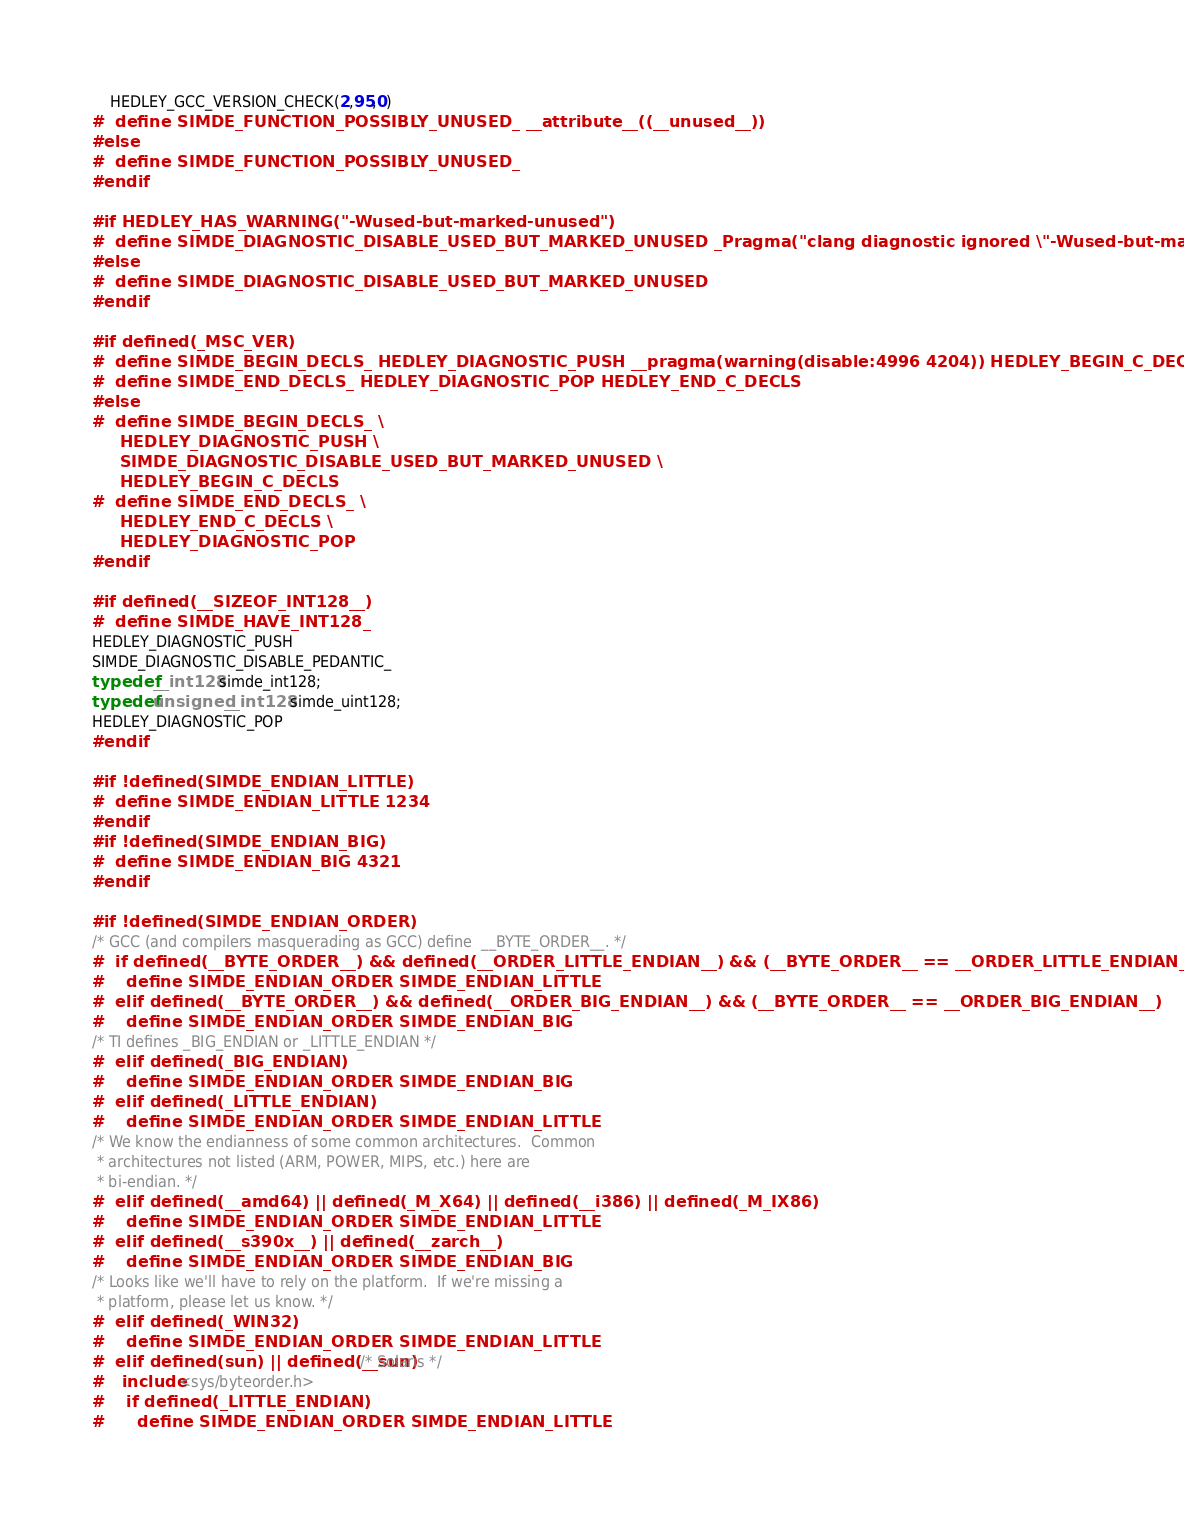<code> <loc_0><loc_0><loc_500><loc_500><_C_>    HEDLEY_GCC_VERSION_CHECK(2,95,0)
#  define SIMDE_FUNCTION_POSSIBLY_UNUSED_ __attribute__((__unused__))
#else
#  define SIMDE_FUNCTION_POSSIBLY_UNUSED_
#endif

#if HEDLEY_HAS_WARNING("-Wused-but-marked-unused")
#  define SIMDE_DIAGNOSTIC_DISABLE_USED_BUT_MARKED_UNUSED _Pragma("clang diagnostic ignored \"-Wused-but-marked-unused\"")
#else
#  define SIMDE_DIAGNOSTIC_DISABLE_USED_BUT_MARKED_UNUSED
#endif

#if defined(_MSC_VER)
#  define SIMDE_BEGIN_DECLS_ HEDLEY_DIAGNOSTIC_PUSH __pragma(warning(disable:4996 4204)) HEDLEY_BEGIN_C_DECLS
#  define SIMDE_END_DECLS_ HEDLEY_DIAGNOSTIC_POP HEDLEY_END_C_DECLS
#else
#  define SIMDE_BEGIN_DECLS_ \
     HEDLEY_DIAGNOSTIC_PUSH \
     SIMDE_DIAGNOSTIC_DISABLE_USED_BUT_MARKED_UNUSED \
     HEDLEY_BEGIN_C_DECLS
#  define SIMDE_END_DECLS_ \
     HEDLEY_END_C_DECLS \
     HEDLEY_DIAGNOSTIC_POP
#endif

#if defined(__SIZEOF_INT128__)
#  define SIMDE_HAVE_INT128_
HEDLEY_DIAGNOSTIC_PUSH
SIMDE_DIAGNOSTIC_DISABLE_PEDANTIC_
typedef __int128 simde_int128;
typedef unsigned __int128 simde_uint128;
HEDLEY_DIAGNOSTIC_POP
#endif

#if !defined(SIMDE_ENDIAN_LITTLE)
#  define SIMDE_ENDIAN_LITTLE 1234
#endif
#if !defined(SIMDE_ENDIAN_BIG)
#  define SIMDE_ENDIAN_BIG 4321
#endif

#if !defined(SIMDE_ENDIAN_ORDER)
/* GCC (and compilers masquerading as GCC) define  __BYTE_ORDER__. */
#  if defined(__BYTE_ORDER__) && defined(__ORDER_LITTLE_ENDIAN__) && (__BYTE_ORDER__ == __ORDER_LITTLE_ENDIAN__)
#    define SIMDE_ENDIAN_ORDER SIMDE_ENDIAN_LITTLE
#  elif defined(__BYTE_ORDER__) && defined(__ORDER_BIG_ENDIAN__) && (__BYTE_ORDER__ == __ORDER_BIG_ENDIAN__)
#    define SIMDE_ENDIAN_ORDER SIMDE_ENDIAN_BIG
/* TI defines _BIG_ENDIAN or _LITTLE_ENDIAN */
#  elif defined(_BIG_ENDIAN)
#    define SIMDE_ENDIAN_ORDER SIMDE_ENDIAN_BIG
#  elif defined(_LITTLE_ENDIAN)
#    define SIMDE_ENDIAN_ORDER SIMDE_ENDIAN_LITTLE
/* We know the endianness of some common architectures.  Common
 * architectures not listed (ARM, POWER, MIPS, etc.) here are
 * bi-endian. */
#  elif defined(__amd64) || defined(_M_X64) || defined(__i386) || defined(_M_IX86)
#    define SIMDE_ENDIAN_ORDER SIMDE_ENDIAN_LITTLE
#  elif defined(__s390x__) || defined(__zarch__)
#    define SIMDE_ENDIAN_ORDER SIMDE_ENDIAN_BIG
/* Looks like we'll have to rely on the platform.  If we're missing a
 * platform, please let us know. */
#  elif defined(_WIN32)
#    define SIMDE_ENDIAN_ORDER SIMDE_ENDIAN_LITTLE
#  elif defined(sun) || defined(__sun) /* Solaris */
#    include <sys/byteorder.h>
#    if defined(_LITTLE_ENDIAN)
#      define SIMDE_ENDIAN_ORDER SIMDE_ENDIAN_LITTLE</code> 